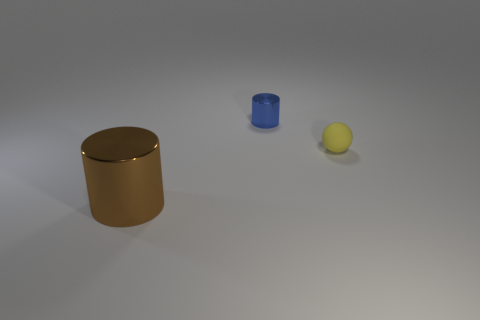What number of blue cylinders have the same size as the matte object?
Your answer should be very brief. 1. What is the shape of the small object that is right of the blue cylinder that is behind the big brown cylinder?
Your response must be concise. Sphere. What shape is the shiny thing behind the object on the left side of the shiny cylinder that is behind the large metallic object?
Make the answer very short. Cylinder. What number of big objects have the same shape as the tiny metal object?
Your response must be concise. 1. What number of cylinders are to the left of the cylinder that is behind the matte ball?
Give a very brief answer. 1. What number of metallic things are tiny yellow balls or small red things?
Give a very brief answer. 0. Are there any yellow things that have the same material as the big brown cylinder?
Provide a short and direct response. No. What number of objects are either tiny objects that are in front of the tiny shiny cylinder or metal cylinders that are behind the brown object?
Your response must be concise. 2. What number of other things are there of the same color as the small metal cylinder?
Offer a terse response. 0. What is the yellow object made of?
Keep it short and to the point. Rubber. 